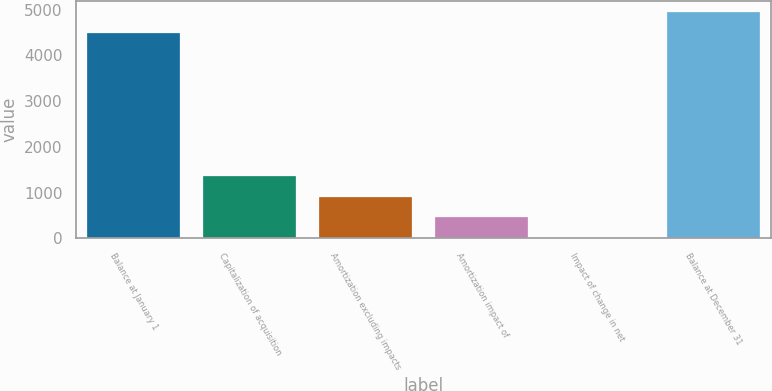Convert chart to OTSL. <chart><loc_0><loc_0><loc_500><loc_500><bar_chart><fcel>Balance at January 1<fcel>Capitalization of acquisition<fcel>Amortization excluding impacts<fcel>Amortization impact of<fcel>Impact of change in net<fcel>Balance at December 31<nl><fcel>4499<fcel>1359.3<fcel>910.2<fcel>461.1<fcel>12<fcel>4948.1<nl></chart> 